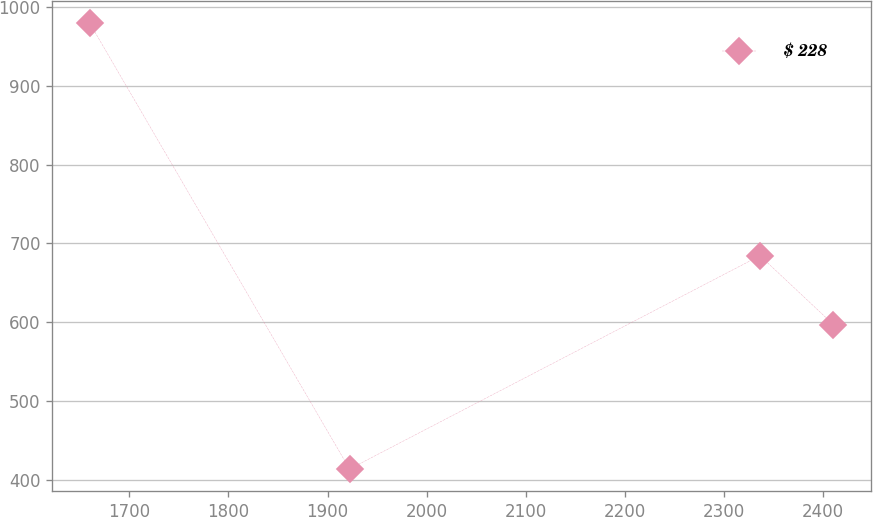<chart> <loc_0><loc_0><loc_500><loc_500><line_chart><ecel><fcel>$ 228<nl><fcel>1659.85<fcel>979.93<nl><fcel>1922.21<fcel>413.73<nl><fcel>2336.34<fcel>684.43<nl><fcel>2410.41<fcel>597.02<nl></chart> 